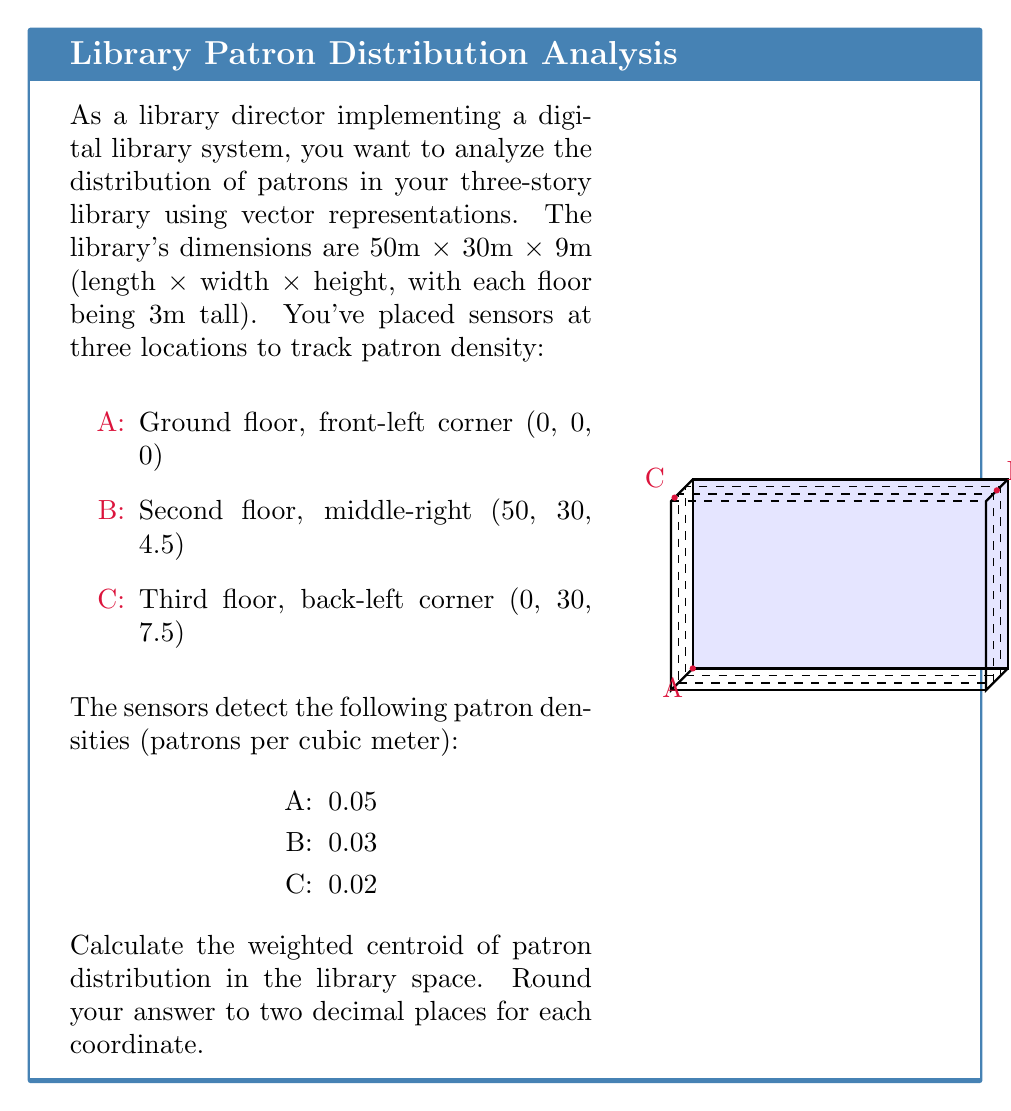Teach me how to tackle this problem. Let's approach this step-by-step:

1) First, we need to represent each sensor location as a vector:
   $\vec{A} = (0, 0, 0)$
   $\vec{B} = (50, 30, 4.5)$
   $\vec{C} = (0, 30, 7.5)$

2) The weighted centroid is calculated using the formula:
   $$\vec{C}_w = \frac{\sum_{i=1}^n w_i \vec{v}_i}{\sum_{i=1}^n w_i}$$
   where $w_i$ are the weights (in this case, patron densities) and $\vec{v}_i$ are the position vectors.

3) Let's calculate the numerator:
   $0.05\vec{A} + 0.03\vec{B} + 0.02\vec{C}$
   $= 0.05(0, 0, 0) + 0.03(50, 30, 4.5) + 0.02(0, 30, 7.5)$
   $= (0, 0, 0) + (1.5, 0.9, 0.135) + (0, 0.6, 0.15)$
   $= (1.5, 1.5, 0.285)$

4) Now, let's calculate the denominator:
   $0.05 + 0.03 + 0.02 = 0.10$

5) Dividing the numerator by the denominator:
   $$\vec{C}_w = \frac{(1.5, 1.5, 0.285)}{0.10} = (15, 15, 2.85)$$

6) Rounding to two decimal places:
   $\vec{C}_w = (15.00, 15.00, 2.85)$
Answer: (15.00, 15.00, 2.85) 